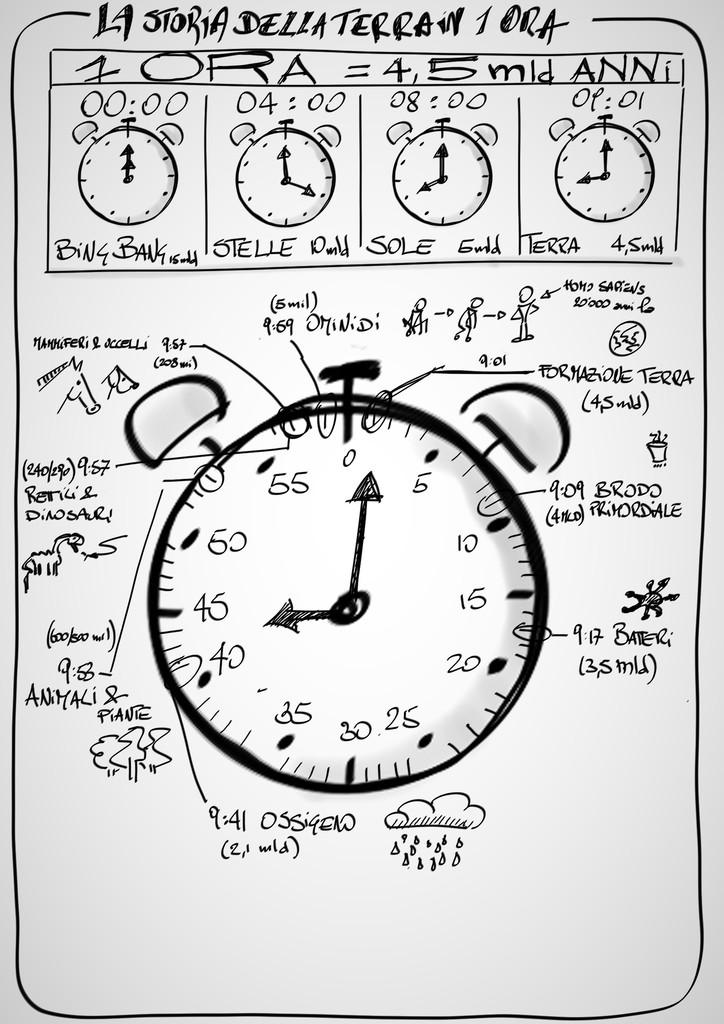<image>
Share a concise interpretation of the image provided. A drawing of an alarm clock has several labels, including stelle, sole, and terra. 